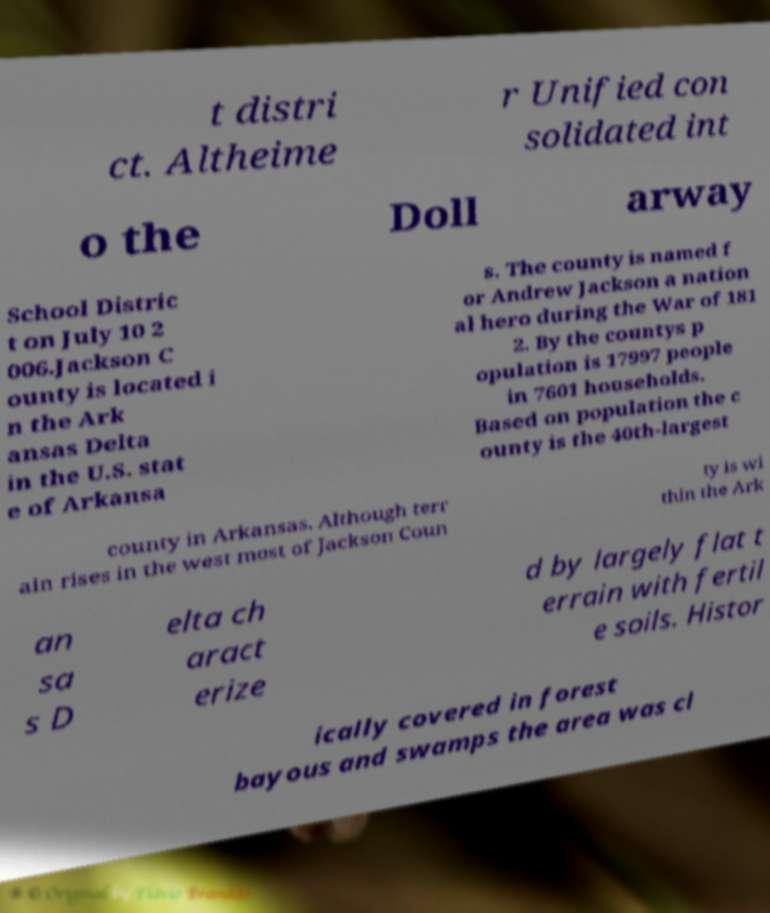Can you accurately transcribe the text from the provided image for me? t distri ct. Altheime r Unified con solidated int o the Doll arway School Distric t on July 10 2 006.Jackson C ounty is located i n the Ark ansas Delta in the U.S. stat e of Arkansa s. The county is named f or Andrew Jackson a nation al hero during the War of 181 2. By the countys p opulation is 17997 people in 7601 households. Based on population the c ounty is the 40th-largest county in Arkansas. Although terr ain rises in the west most of Jackson Coun ty is wi thin the Ark an sa s D elta ch aract erize d by largely flat t errain with fertil e soils. Histor ically covered in forest bayous and swamps the area was cl 